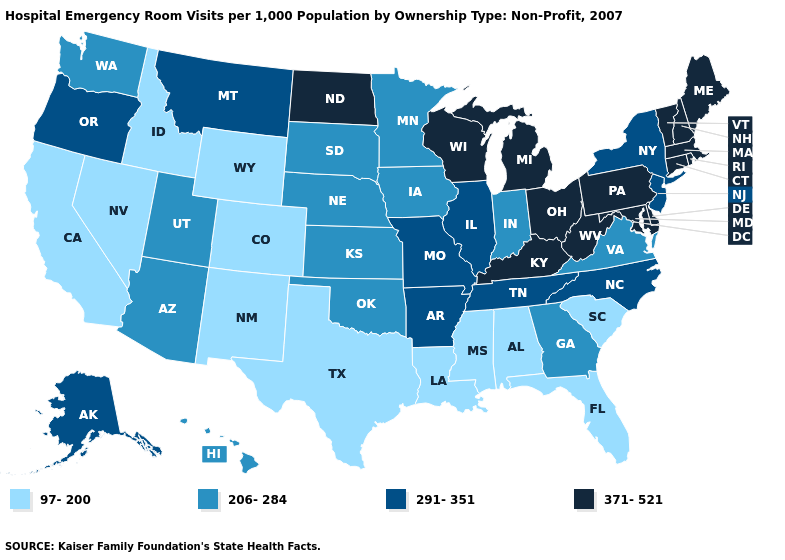Name the states that have a value in the range 206-284?
Quick response, please. Arizona, Georgia, Hawaii, Indiana, Iowa, Kansas, Minnesota, Nebraska, Oklahoma, South Dakota, Utah, Virginia, Washington. Among the states that border Arizona , which have the lowest value?
Give a very brief answer. California, Colorado, Nevada, New Mexico. Does New Jersey have the highest value in the Northeast?
Answer briefly. No. Among the states that border Minnesota , does North Dakota have the highest value?
Write a very short answer. Yes. How many symbols are there in the legend?
Short answer required. 4. What is the value of Wisconsin?
Give a very brief answer. 371-521. Name the states that have a value in the range 206-284?
Keep it brief. Arizona, Georgia, Hawaii, Indiana, Iowa, Kansas, Minnesota, Nebraska, Oklahoma, South Dakota, Utah, Virginia, Washington. What is the value of Kansas?
Keep it brief. 206-284. Does Montana have the highest value in the West?
Answer briefly. Yes. Does New Mexico have a lower value than Nebraska?
Write a very short answer. Yes. Name the states that have a value in the range 291-351?
Quick response, please. Alaska, Arkansas, Illinois, Missouri, Montana, New Jersey, New York, North Carolina, Oregon, Tennessee. Does South Dakota have the lowest value in the USA?
Write a very short answer. No. Does Louisiana have the lowest value in the South?
Be succinct. Yes. What is the value of Vermont?
Write a very short answer. 371-521. Which states have the highest value in the USA?
Be succinct. Connecticut, Delaware, Kentucky, Maine, Maryland, Massachusetts, Michigan, New Hampshire, North Dakota, Ohio, Pennsylvania, Rhode Island, Vermont, West Virginia, Wisconsin. 